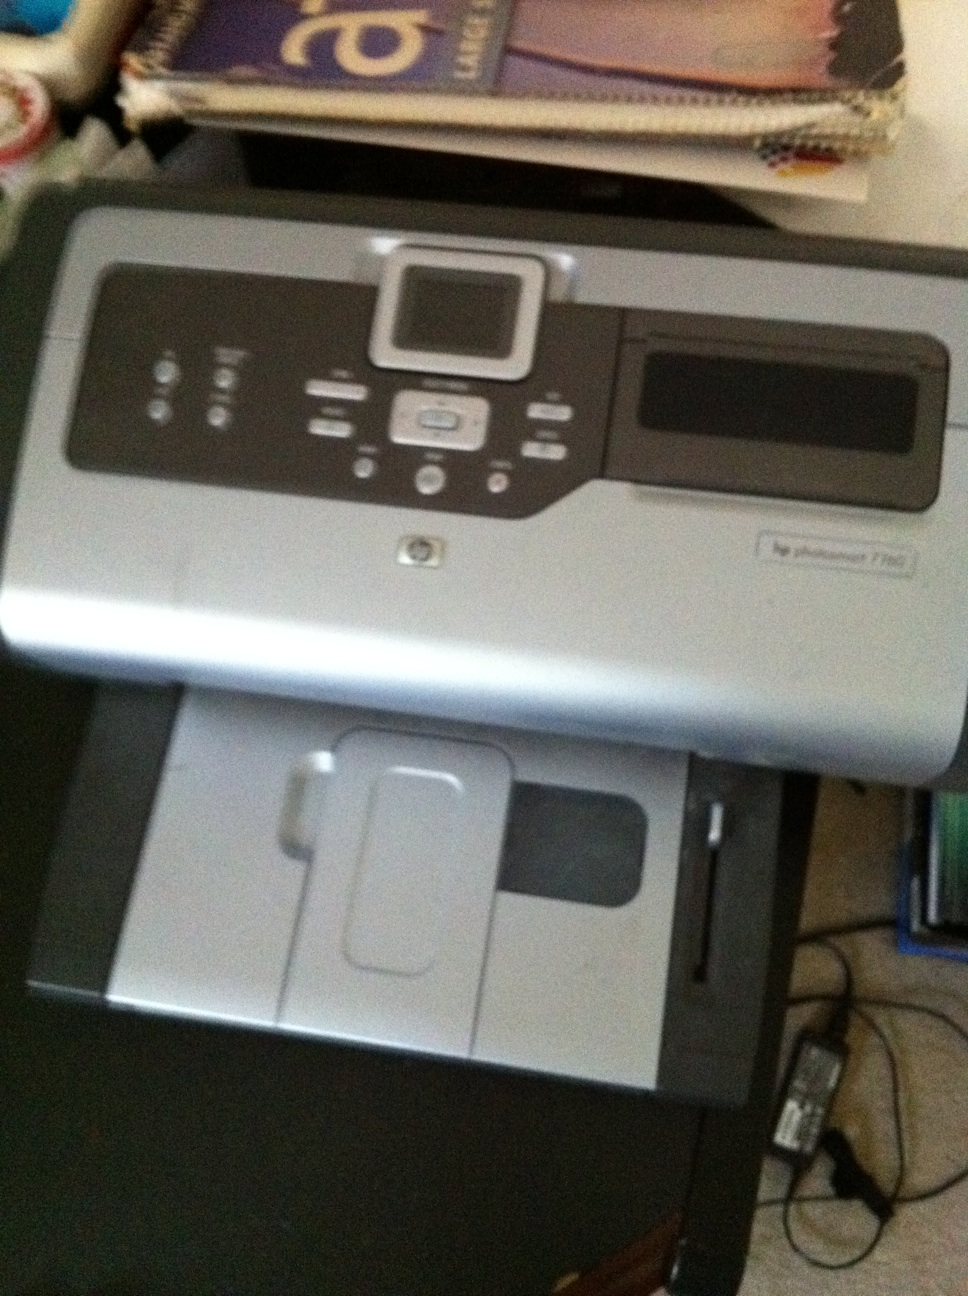What's the model number and manufacturer of this printer? The image shows an HP Photosmart 7280 printer. It is manufactured by Hewlett-Packard (HP). 